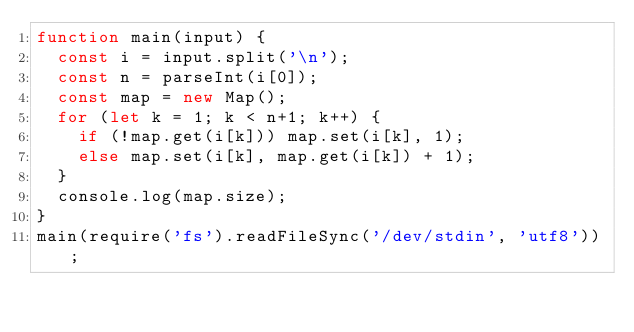<code> <loc_0><loc_0><loc_500><loc_500><_JavaScript_>function main(input) {
  const i = input.split('\n');
  const n = parseInt(i[0]);
  const map = new Map();
  for (let k = 1; k < n+1; k++) {
  	if (!map.get(i[k])) map.set(i[k], 1);
    else map.set(i[k], map.get(i[k]) + 1);
  }
  console.log(map.size);
}
main(require('fs').readFileSync('/dev/stdin', 'utf8'));</code> 